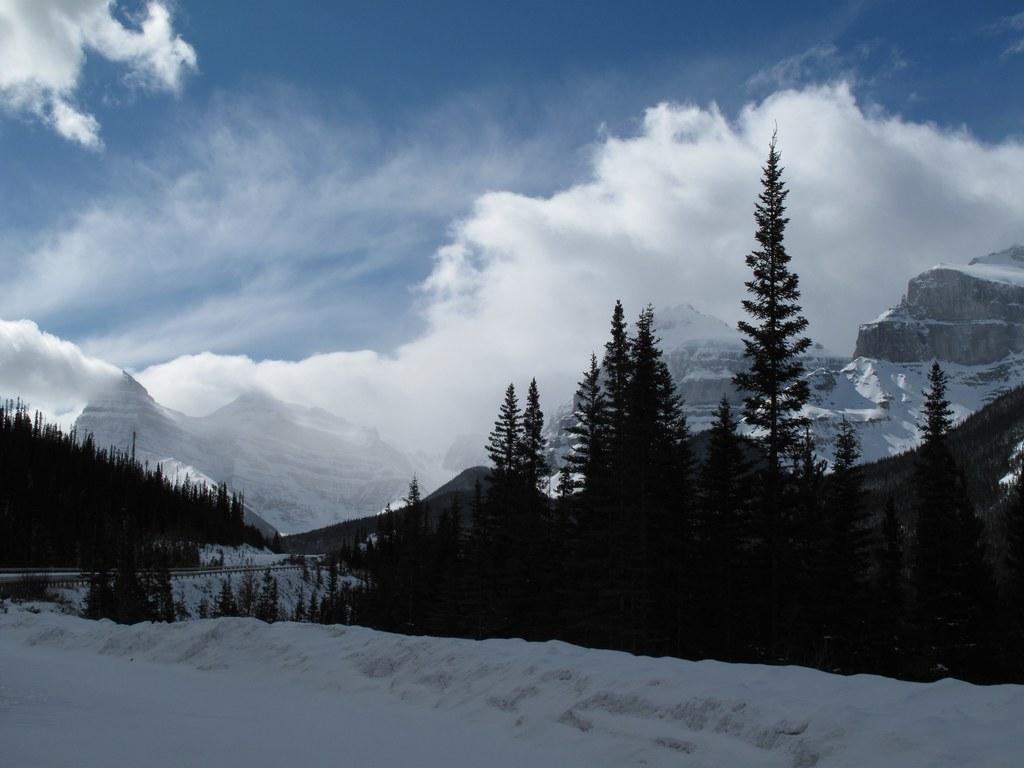Can you describe this image briefly? In this image we can see snow on the ground, trees and in the background we can see snow on the mountains and clouds in the sky. 